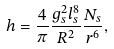Convert formula to latex. <formula><loc_0><loc_0><loc_500><loc_500>h = \frac { 4 } { \pi } \frac { g _ { s } ^ { 2 } l _ { s } ^ { 8 } } { R ^ { 2 } } \frac { N _ { s } } { r ^ { 6 } } ,</formula> 